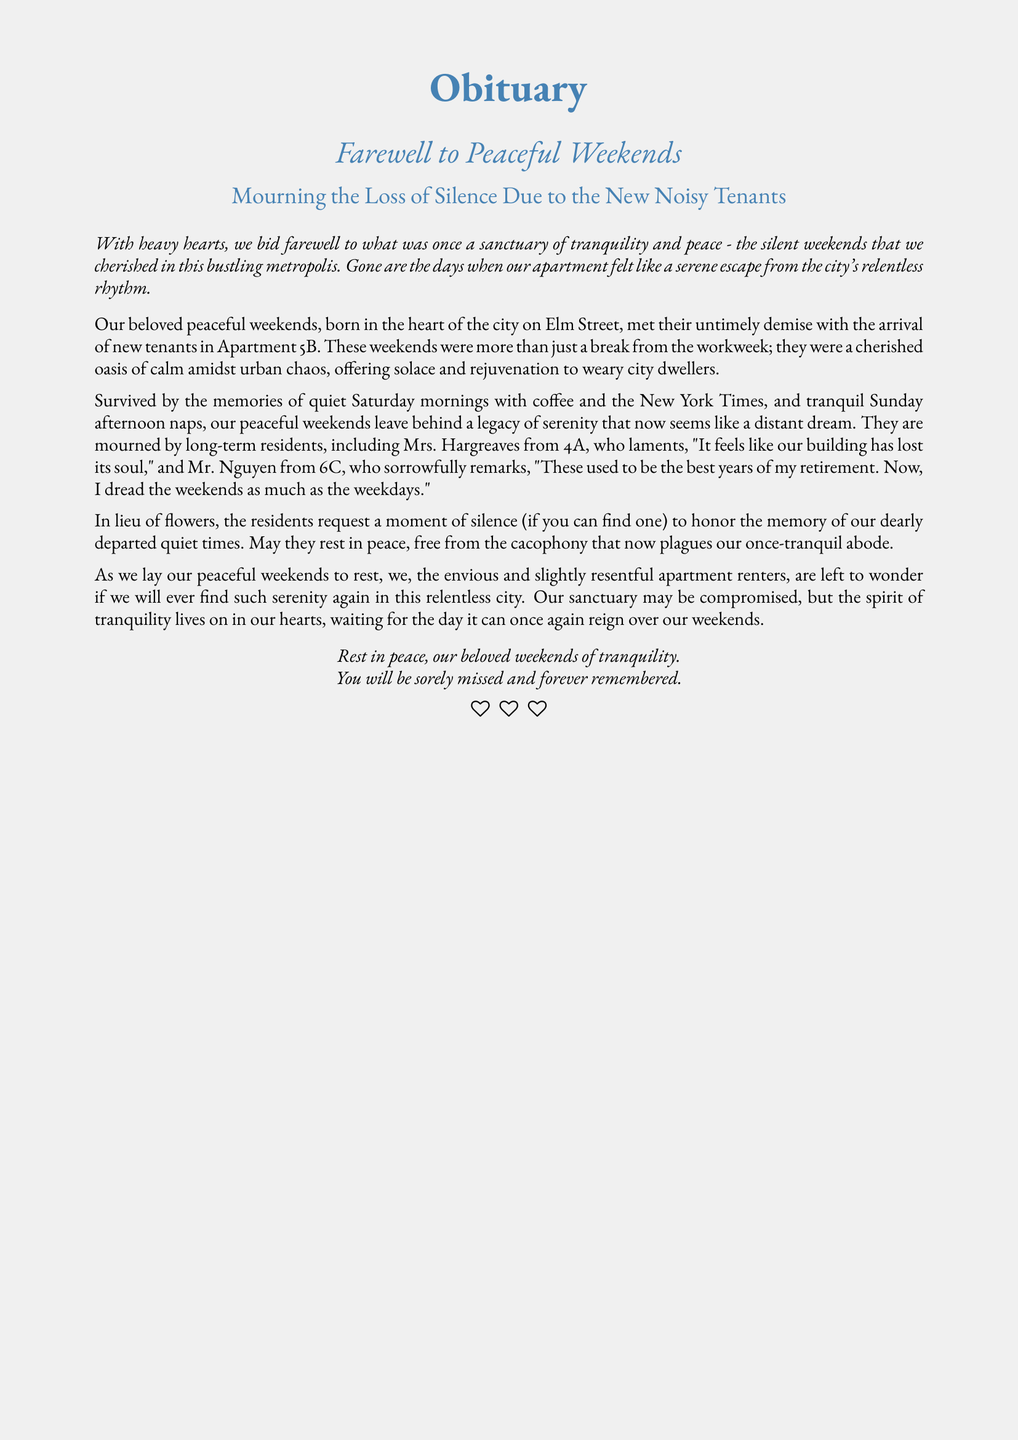what is the title of the document? The title is clearly stated at the beginning of the obituary section.
Answer: Obituary who are the new tenants mentioned in the document? The document references the new tenants living in Apartment 5B, indicating their importance in the narrative.
Answer: Apartment 5B what is the location of the peaceful weekends? The document specifies the city and street where these weekends were experienced and mourned, providing a context to the residents' sentiments.
Answer: Elm Street who from Apartment 4A is mourning the loss of silence? The document mentions a resident from 4A who expresses her feelings about the loss of peace.
Answer: Mrs. Hargreaves what type of moments do the residents remember fondly? The document discusses cherished activities that were part of the peaceful weekends, describing the atmosphere residents wish to revive.
Answer: Quiet Saturday mornings how do the residents feel about the new noise? The document includes statements expressing how the residents perceive the changes in their living environment due to new tenants.
Answer: Dread what do residents request in lieu of flowers? This request indicates a hope for remembrance in the face of loss, connecting to the theme of honoring what has been lost.
Answer: Moment of silence how do the residents feel about their once peaceful environment now? This inquiry examines the deeper emotional response of the residents as they reflect on their altered living situation.
Answer: Compromised what is the overall tone of the document? Given its purpose and the way it presents the loss, the tone reflects a specific emotional state associated with the events.
Answer: Mourning 